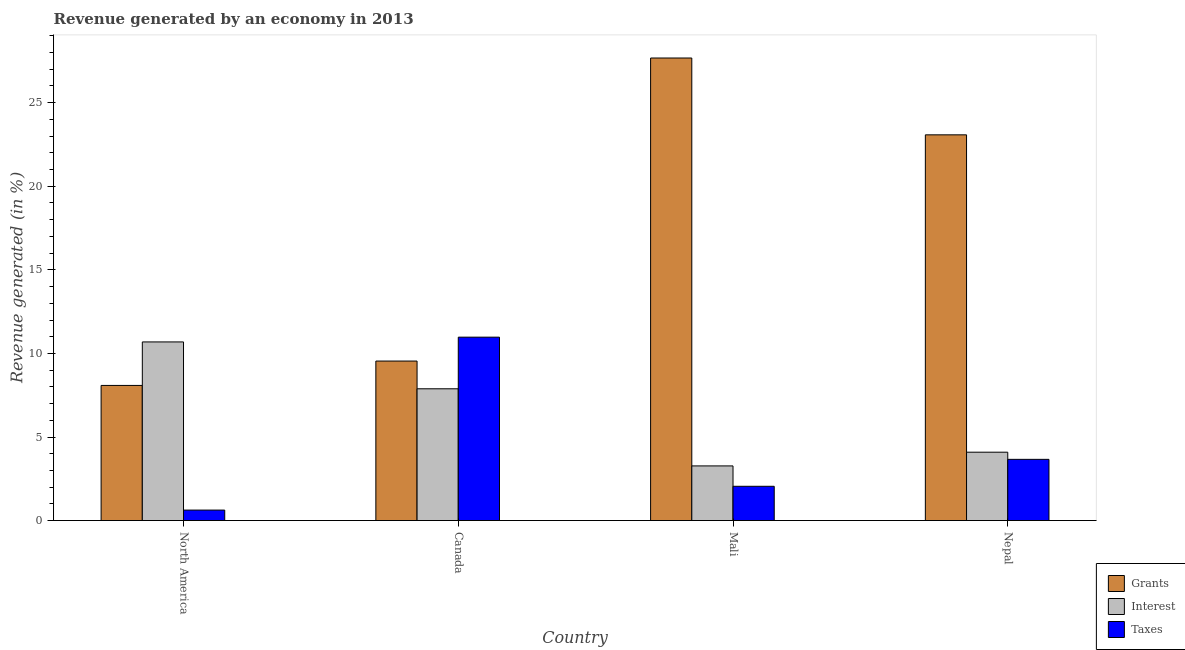How many different coloured bars are there?
Your response must be concise. 3. How many groups of bars are there?
Give a very brief answer. 4. Are the number of bars on each tick of the X-axis equal?
Offer a very short reply. Yes. What is the label of the 4th group of bars from the left?
Provide a short and direct response. Nepal. In how many cases, is the number of bars for a given country not equal to the number of legend labels?
Your response must be concise. 0. What is the percentage of revenue generated by taxes in Mali?
Your response must be concise. 2.05. Across all countries, what is the maximum percentage of revenue generated by taxes?
Your response must be concise. 10.97. Across all countries, what is the minimum percentage of revenue generated by interest?
Your answer should be compact. 3.27. In which country was the percentage of revenue generated by interest minimum?
Your response must be concise. Mali. What is the total percentage of revenue generated by taxes in the graph?
Your answer should be very brief. 17.32. What is the difference between the percentage of revenue generated by interest in Canada and that in Nepal?
Your answer should be compact. 3.79. What is the difference between the percentage of revenue generated by grants in Mali and the percentage of revenue generated by taxes in North America?
Ensure brevity in your answer.  27.05. What is the average percentage of revenue generated by interest per country?
Provide a succinct answer. 6.48. What is the difference between the percentage of revenue generated by interest and percentage of revenue generated by grants in Canada?
Your answer should be very brief. -1.66. In how many countries, is the percentage of revenue generated by taxes greater than 10 %?
Offer a very short reply. 1. What is the ratio of the percentage of revenue generated by taxes in Canada to that in Nepal?
Offer a very short reply. 3. Is the percentage of revenue generated by interest in Mali less than that in North America?
Make the answer very short. Yes. What is the difference between the highest and the second highest percentage of revenue generated by grants?
Offer a terse response. 4.6. What is the difference between the highest and the lowest percentage of revenue generated by taxes?
Provide a succinct answer. 10.34. Is the sum of the percentage of revenue generated by grants in Mali and North America greater than the maximum percentage of revenue generated by taxes across all countries?
Make the answer very short. Yes. What does the 1st bar from the left in Canada represents?
Keep it short and to the point. Grants. What does the 3rd bar from the right in Canada represents?
Keep it short and to the point. Grants. Is it the case that in every country, the sum of the percentage of revenue generated by grants and percentage of revenue generated by interest is greater than the percentage of revenue generated by taxes?
Provide a succinct answer. Yes. How many countries are there in the graph?
Give a very brief answer. 4. Where does the legend appear in the graph?
Your answer should be very brief. Bottom right. What is the title of the graph?
Your answer should be compact. Revenue generated by an economy in 2013. Does "Social Insurance" appear as one of the legend labels in the graph?
Your response must be concise. No. What is the label or title of the X-axis?
Provide a short and direct response. Country. What is the label or title of the Y-axis?
Provide a short and direct response. Revenue generated (in %). What is the Revenue generated (in %) of Grants in North America?
Offer a terse response. 8.09. What is the Revenue generated (in %) in Interest in North America?
Your response must be concise. 10.69. What is the Revenue generated (in %) of Taxes in North America?
Give a very brief answer. 0.63. What is the Revenue generated (in %) of Grants in Canada?
Your answer should be compact. 9.54. What is the Revenue generated (in %) of Interest in Canada?
Offer a terse response. 7.88. What is the Revenue generated (in %) of Taxes in Canada?
Provide a succinct answer. 10.97. What is the Revenue generated (in %) of Grants in Mali?
Keep it short and to the point. 27.67. What is the Revenue generated (in %) of Interest in Mali?
Keep it short and to the point. 3.27. What is the Revenue generated (in %) of Taxes in Mali?
Your answer should be very brief. 2.05. What is the Revenue generated (in %) in Grants in Nepal?
Keep it short and to the point. 23.08. What is the Revenue generated (in %) of Interest in Nepal?
Give a very brief answer. 4.09. What is the Revenue generated (in %) in Taxes in Nepal?
Keep it short and to the point. 3.66. Across all countries, what is the maximum Revenue generated (in %) in Grants?
Keep it short and to the point. 27.67. Across all countries, what is the maximum Revenue generated (in %) in Interest?
Give a very brief answer. 10.69. Across all countries, what is the maximum Revenue generated (in %) of Taxes?
Your response must be concise. 10.97. Across all countries, what is the minimum Revenue generated (in %) in Grants?
Your answer should be compact. 8.09. Across all countries, what is the minimum Revenue generated (in %) of Interest?
Ensure brevity in your answer.  3.27. Across all countries, what is the minimum Revenue generated (in %) in Taxes?
Make the answer very short. 0.63. What is the total Revenue generated (in %) of Grants in the graph?
Provide a succinct answer. 68.38. What is the total Revenue generated (in %) in Interest in the graph?
Provide a short and direct response. 25.94. What is the total Revenue generated (in %) of Taxes in the graph?
Your answer should be very brief. 17.32. What is the difference between the Revenue generated (in %) of Grants in North America and that in Canada?
Keep it short and to the point. -1.46. What is the difference between the Revenue generated (in %) in Interest in North America and that in Canada?
Provide a succinct answer. 2.8. What is the difference between the Revenue generated (in %) of Taxes in North America and that in Canada?
Offer a very short reply. -10.34. What is the difference between the Revenue generated (in %) of Grants in North America and that in Mali?
Your answer should be compact. -19.59. What is the difference between the Revenue generated (in %) in Interest in North America and that in Mali?
Your response must be concise. 7.42. What is the difference between the Revenue generated (in %) of Taxes in North America and that in Mali?
Provide a succinct answer. -1.42. What is the difference between the Revenue generated (in %) in Grants in North America and that in Nepal?
Keep it short and to the point. -14.99. What is the difference between the Revenue generated (in %) of Interest in North America and that in Nepal?
Provide a short and direct response. 6.6. What is the difference between the Revenue generated (in %) of Taxes in North America and that in Nepal?
Provide a succinct answer. -3.03. What is the difference between the Revenue generated (in %) in Grants in Canada and that in Mali?
Ensure brevity in your answer.  -18.13. What is the difference between the Revenue generated (in %) in Interest in Canada and that in Mali?
Offer a terse response. 4.61. What is the difference between the Revenue generated (in %) of Taxes in Canada and that in Mali?
Ensure brevity in your answer.  8.92. What is the difference between the Revenue generated (in %) in Grants in Canada and that in Nepal?
Offer a terse response. -13.53. What is the difference between the Revenue generated (in %) in Interest in Canada and that in Nepal?
Make the answer very short. 3.79. What is the difference between the Revenue generated (in %) in Taxes in Canada and that in Nepal?
Provide a succinct answer. 7.31. What is the difference between the Revenue generated (in %) of Grants in Mali and that in Nepal?
Provide a short and direct response. 4.6. What is the difference between the Revenue generated (in %) of Interest in Mali and that in Nepal?
Your response must be concise. -0.82. What is the difference between the Revenue generated (in %) of Taxes in Mali and that in Nepal?
Provide a succinct answer. -1.61. What is the difference between the Revenue generated (in %) of Grants in North America and the Revenue generated (in %) of Interest in Canada?
Your answer should be compact. 0.2. What is the difference between the Revenue generated (in %) in Grants in North America and the Revenue generated (in %) in Taxes in Canada?
Make the answer very short. -2.89. What is the difference between the Revenue generated (in %) of Interest in North America and the Revenue generated (in %) of Taxes in Canada?
Your answer should be very brief. -0.28. What is the difference between the Revenue generated (in %) in Grants in North America and the Revenue generated (in %) in Interest in Mali?
Your answer should be compact. 4.81. What is the difference between the Revenue generated (in %) in Grants in North America and the Revenue generated (in %) in Taxes in Mali?
Your answer should be compact. 6.03. What is the difference between the Revenue generated (in %) of Interest in North America and the Revenue generated (in %) of Taxes in Mali?
Give a very brief answer. 8.64. What is the difference between the Revenue generated (in %) in Grants in North America and the Revenue generated (in %) in Interest in Nepal?
Offer a very short reply. 3.99. What is the difference between the Revenue generated (in %) of Grants in North America and the Revenue generated (in %) of Taxes in Nepal?
Your answer should be very brief. 4.42. What is the difference between the Revenue generated (in %) of Interest in North America and the Revenue generated (in %) of Taxes in Nepal?
Provide a succinct answer. 7.03. What is the difference between the Revenue generated (in %) of Grants in Canada and the Revenue generated (in %) of Interest in Mali?
Your answer should be compact. 6.27. What is the difference between the Revenue generated (in %) of Grants in Canada and the Revenue generated (in %) of Taxes in Mali?
Your answer should be very brief. 7.49. What is the difference between the Revenue generated (in %) in Interest in Canada and the Revenue generated (in %) in Taxes in Mali?
Keep it short and to the point. 5.83. What is the difference between the Revenue generated (in %) in Grants in Canada and the Revenue generated (in %) in Interest in Nepal?
Make the answer very short. 5.45. What is the difference between the Revenue generated (in %) of Grants in Canada and the Revenue generated (in %) of Taxes in Nepal?
Your answer should be very brief. 5.88. What is the difference between the Revenue generated (in %) in Interest in Canada and the Revenue generated (in %) in Taxes in Nepal?
Offer a terse response. 4.22. What is the difference between the Revenue generated (in %) of Grants in Mali and the Revenue generated (in %) of Interest in Nepal?
Your response must be concise. 23.58. What is the difference between the Revenue generated (in %) in Grants in Mali and the Revenue generated (in %) in Taxes in Nepal?
Provide a short and direct response. 24.01. What is the difference between the Revenue generated (in %) in Interest in Mali and the Revenue generated (in %) in Taxes in Nepal?
Give a very brief answer. -0.39. What is the average Revenue generated (in %) in Grants per country?
Keep it short and to the point. 17.1. What is the average Revenue generated (in %) in Interest per country?
Provide a succinct answer. 6.48. What is the average Revenue generated (in %) in Taxes per country?
Offer a terse response. 4.33. What is the difference between the Revenue generated (in %) in Grants and Revenue generated (in %) in Interest in North America?
Ensure brevity in your answer.  -2.6. What is the difference between the Revenue generated (in %) in Grants and Revenue generated (in %) in Taxes in North America?
Your response must be concise. 7.46. What is the difference between the Revenue generated (in %) in Interest and Revenue generated (in %) in Taxes in North America?
Keep it short and to the point. 10.06. What is the difference between the Revenue generated (in %) of Grants and Revenue generated (in %) of Interest in Canada?
Provide a succinct answer. 1.66. What is the difference between the Revenue generated (in %) of Grants and Revenue generated (in %) of Taxes in Canada?
Offer a very short reply. -1.43. What is the difference between the Revenue generated (in %) in Interest and Revenue generated (in %) in Taxes in Canada?
Give a very brief answer. -3.09. What is the difference between the Revenue generated (in %) of Grants and Revenue generated (in %) of Interest in Mali?
Provide a succinct answer. 24.4. What is the difference between the Revenue generated (in %) of Grants and Revenue generated (in %) of Taxes in Mali?
Give a very brief answer. 25.62. What is the difference between the Revenue generated (in %) of Interest and Revenue generated (in %) of Taxes in Mali?
Provide a succinct answer. 1.22. What is the difference between the Revenue generated (in %) in Grants and Revenue generated (in %) in Interest in Nepal?
Make the answer very short. 18.99. What is the difference between the Revenue generated (in %) of Grants and Revenue generated (in %) of Taxes in Nepal?
Offer a terse response. 19.41. What is the difference between the Revenue generated (in %) of Interest and Revenue generated (in %) of Taxes in Nepal?
Give a very brief answer. 0.43. What is the ratio of the Revenue generated (in %) in Grants in North America to that in Canada?
Make the answer very short. 0.85. What is the ratio of the Revenue generated (in %) of Interest in North America to that in Canada?
Make the answer very short. 1.36. What is the ratio of the Revenue generated (in %) in Taxes in North America to that in Canada?
Offer a terse response. 0.06. What is the ratio of the Revenue generated (in %) of Grants in North America to that in Mali?
Your response must be concise. 0.29. What is the ratio of the Revenue generated (in %) of Interest in North America to that in Mali?
Give a very brief answer. 3.27. What is the ratio of the Revenue generated (in %) in Taxes in North America to that in Mali?
Give a very brief answer. 0.31. What is the ratio of the Revenue generated (in %) of Grants in North America to that in Nepal?
Offer a very short reply. 0.35. What is the ratio of the Revenue generated (in %) in Interest in North America to that in Nepal?
Offer a terse response. 2.61. What is the ratio of the Revenue generated (in %) in Taxes in North America to that in Nepal?
Provide a succinct answer. 0.17. What is the ratio of the Revenue generated (in %) of Grants in Canada to that in Mali?
Your response must be concise. 0.34. What is the ratio of the Revenue generated (in %) of Interest in Canada to that in Mali?
Ensure brevity in your answer.  2.41. What is the ratio of the Revenue generated (in %) in Taxes in Canada to that in Mali?
Ensure brevity in your answer.  5.35. What is the ratio of the Revenue generated (in %) in Grants in Canada to that in Nepal?
Provide a short and direct response. 0.41. What is the ratio of the Revenue generated (in %) in Interest in Canada to that in Nepal?
Your answer should be compact. 1.93. What is the ratio of the Revenue generated (in %) of Taxes in Canada to that in Nepal?
Ensure brevity in your answer.  3. What is the ratio of the Revenue generated (in %) in Grants in Mali to that in Nepal?
Ensure brevity in your answer.  1.2. What is the ratio of the Revenue generated (in %) of Interest in Mali to that in Nepal?
Make the answer very short. 0.8. What is the ratio of the Revenue generated (in %) of Taxes in Mali to that in Nepal?
Your answer should be compact. 0.56. What is the difference between the highest and the second highest Revenue generated (in %) of Grants?
Make the answer very short. 4.6. What is the difference between the highest and the second highest Revenue generated (in %) in Interest?
Provide a short and direct response. 2.8. What is the difference between the highest and the second highest Revenue generated (in %) of Taxes?
Offer a terse response. 7.31. What is the difference between the highest and the lowest Revenue generated (in %) in Grants?
Your answer should be compact. 19.59. What is the difference between the highest and the lowest Revenue generated (in %) in Interest?
Give a very brief answer. 7.42. What is the difference between the highest and the lowest Revenue generated (in %) in Taxes?
Give a very brief answer. 10.34. 